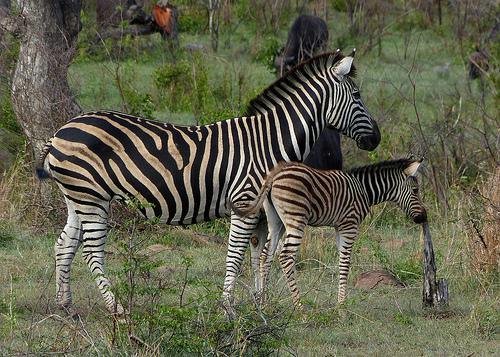Question: why the small zebra is with big one?
Choices:
A. To be fed.
B. To be protected.
C. To learn how to survive.
D. To hide from predators.
Answer with the letter. Answer: B Question: how many zebras are in the field?
Choices:
A. Two.
B. Three.
C. One.
D. Zero.
Answer with the letter. Answer: A Question: who is feeding the zebra?
Choices:
A. No one.
B. The mother.
C. A person.
D. The plant.
Answer with the letter. Answer: A Question: when did the zebras arrived?
Choices:
A. Yesterday.
B. Earlier.
C. Last week.
D. A month ago.
Answer with the letter. Answer: B Question: where are the zebras?
Choices:
A. Behind the fence.
B. In the field.
C. At the river.
D. In the coral.
Answer with the letter. Answer: B Question: what is the color of the grass?
Choices:
A. Yellow.
B. Green.
C. Brown.
D. Blue.
Answer with the letter. Answer: B 